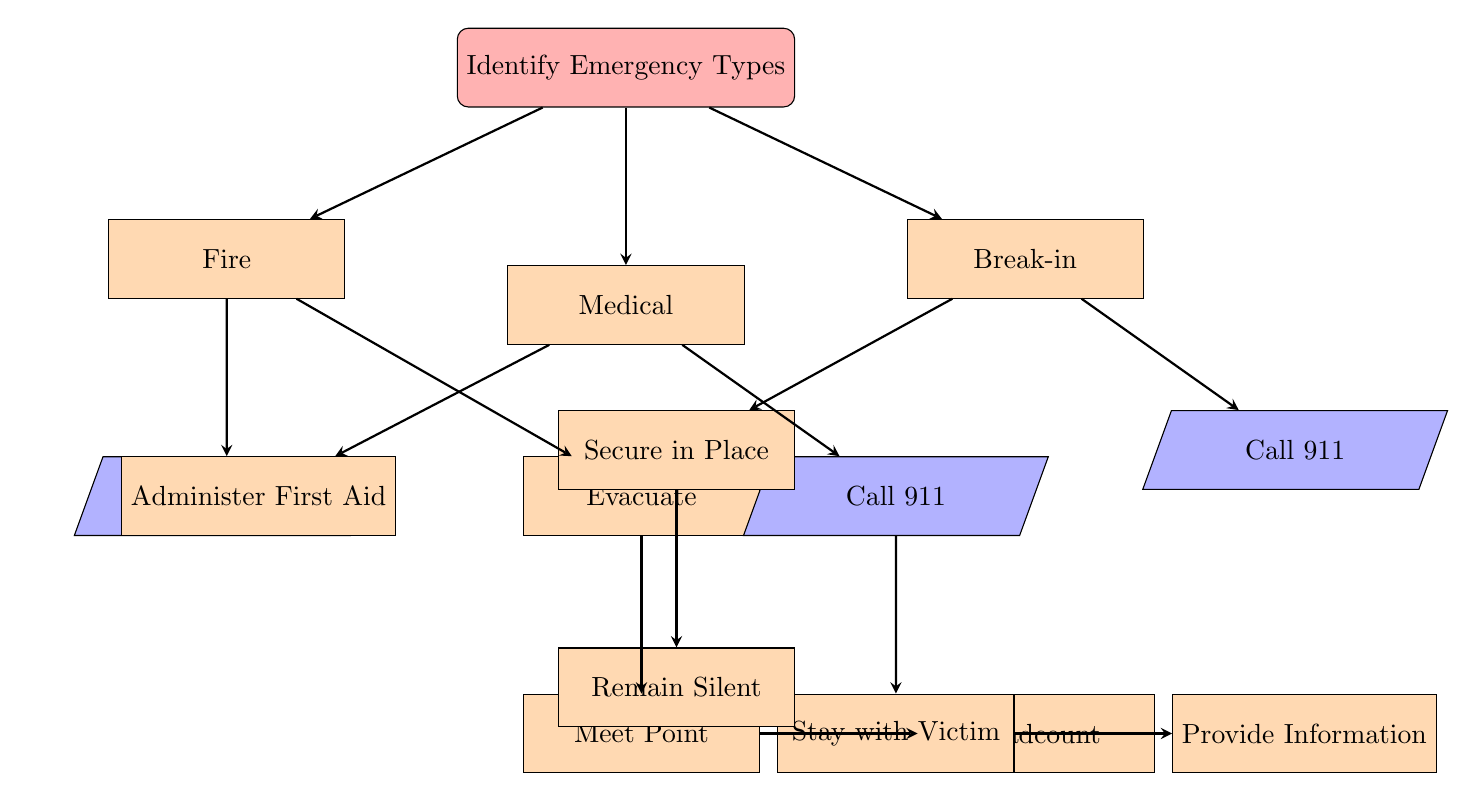What is the first step in the communication plan? The first step in the communication plan is to identify the types of emergencies that could occur. This is indicated by the starting node in the diagram.
Answer: Identify Emergency Types How many emergency types are identified? The diagram shows three types of emergencies: Fire, Medical, and Break-in. By counting the children nodes of the initial node, we find three distinct types.
Answer: 3 What action follows a fire emergency? In the case of a fire emergency, the first action is to call 911, which is directly connected from the fire node in the diagram.
Answer: Call 911 What do you do after calling 911 for a medical emergency? After calling 911 for a medical emergency, the next step is to stay with the victim until help arrives. This is shown as a subsequent action after calling 911 from the medical node.
Answer: Stay with Victim In the break-in scenario, what action is taken after securing in place? After securing in place during a break-in, the next action is to remain silent until law enforcement arrives. This follows the secure in place action as shown in the diagram.
Answer: Remain Silent Which emergency type requires administering first aid? The medical emergency requires administering first aid, as indicated by the specific node under the medical type in the diagram.
Answer: Medical What is the last step in the action for a fire emergency? The last step after evacuating and meeting at the designated point is to conduct a headcount to ensure everyone is safe, as depicted in the diagram.
Answer: Headcount How many actions follow the medical emergency type? There are three actions that follow the medical emergency: Administer First Aid, Call 911, and Stay with Victim. Counting the direct links from the medical node confirms this.
Answer: 3 What is the second action in the fire emergency procedure? The second action in the fire emergency procedure is to evacuate, which comes after calling 911. The diagram clearly shows this sequence.
Answer: Evacuate 